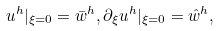Convert formula to latex. <formula><loc_0><loc_0><loc_500><loc_500>u ^ { h } | _ { \xi = 0 } = \bar { w } ^ { h } , \partial _ { \xi } u ^ { h } | _ { \xi = 0 } = \hat { w } ^ { h } ,</formula> 